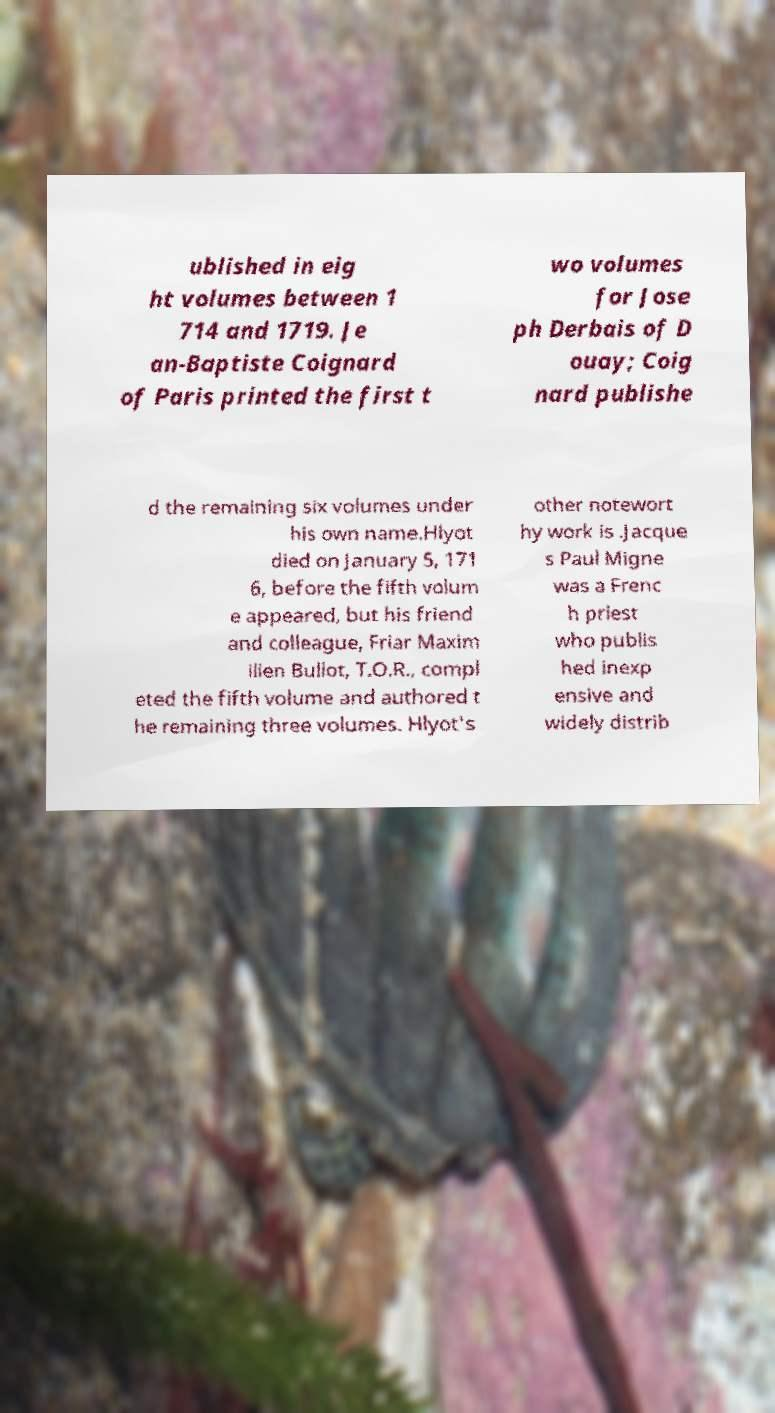Could you extract and type out the text from this image? ublished in eig ht volumes between 1 714 and 1719. Je an-Baptiste Coignard of Paris printed the first t wo volumes for Jose ph Derbais of D ouay; Coig nard publishe d the remaining six volumes under his own name.Hlyot died on January 5, 171 6, before the fifth volum e appeared, but his friend and colleague, Friar Maxim ilien Bullot, T.O.R., compl eted the fifth volume and authored t he remaining three volumes. Hlyot's other notewort hy work is .Jacque s Paul Migne was a Frenc h priest who publis hed inexp ensive and widely distrib 